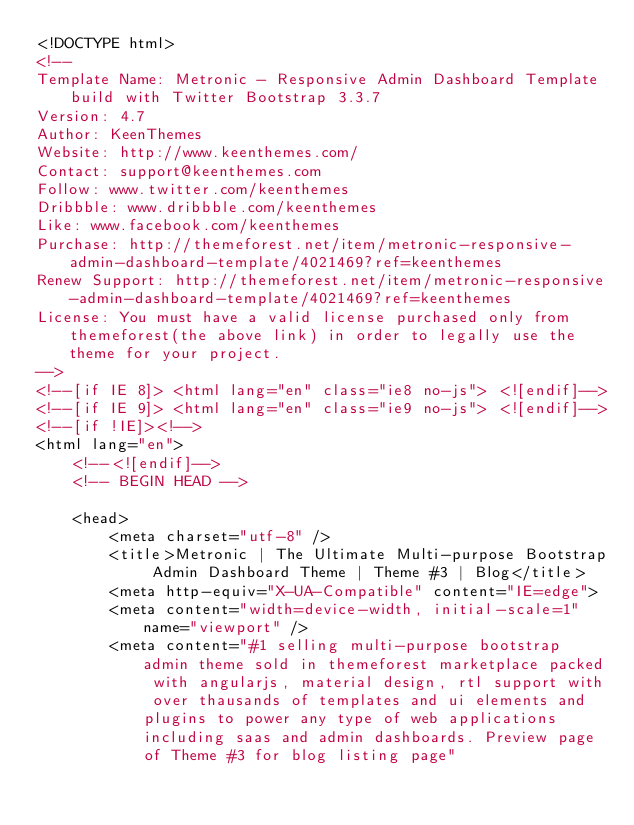<code> <loc_0><loc_0><loc_500><loc_500><_HTML_><!DOCTYPE html>
<!-- 
Template Name: Metronic - Responsive Admin Dashboard Template build with Twitter Bootstrap 3.3.7
Version: 4.7
Author: KeenThemes
Website: http://www.keenthemes.com/
Contact: support@keenthemes.com
Follow: www.twitter.com/keenthemes
Dribbble: www.dribbble.com/keenthemes
Like: www.facebook.com/keenthemes
Purchase: http://themeforest.net/item/metronic-responsive-admin-dashboard-template/4021469?ref=keenthemes
Renew Support: http://themeforest.net/item/metronic-responsive-admin-dashboard-template/4021469?ref=keenthemes
License: You must have a valid license purchased only from themeforest(the above link) in order to legally use the theme for your project.
-->
<!--[if IE 8]> <html lang="en" class="ie8 no-js"> <![endif]-->
<!--[if IE 9]> <html lang="en" class="ie9 no-js"> <![endif]-->
<!--[if !IE]><!-->
<html lang="en">
    <!--<![endif]-->
    <!-- BEGIN HEAD -->

    <head>
        <meta charset="utf-8" />
        <title>Metronic | The Ultimate Multi-purpose Bootstrap Admin Dashboard Theme | Theme #3 | Blog</title>
        <meta http-equiv="X-UA-Compatible" content="IE=edge">
        <meta content="width=device-width, initial-scale=1" name="viewport" />
        <meta content="#1 selling multi-purpose bootstrap admin theme sold in themeforest marketplace packed with angularjs, material design, rtl support with over thausands of templates and ui elements and plugins to power any type of web applications including saas and admin dashboards. Preview page of Theme #3 for blog listing page"</code> 